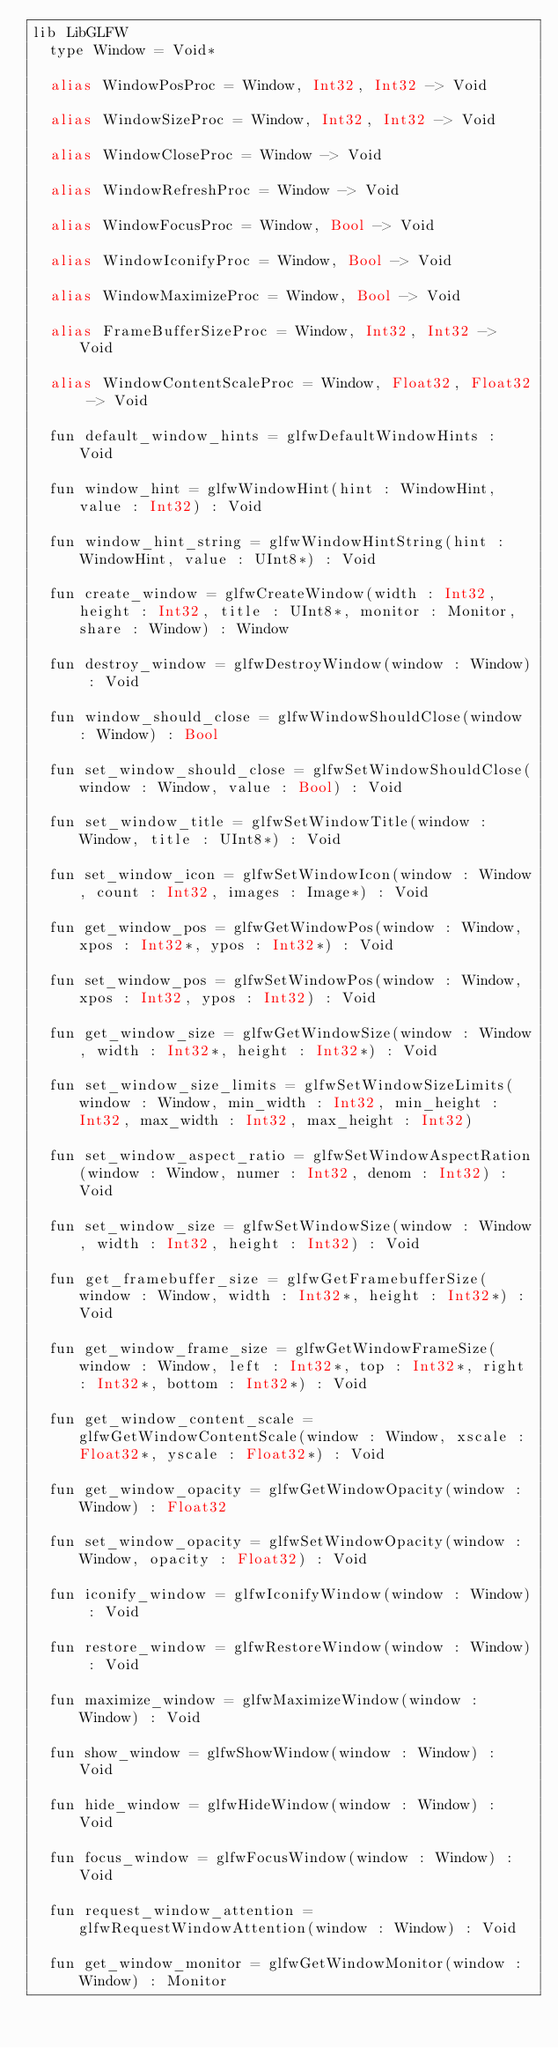Convert code to text. <code><loc_0><loc_0><loc_500><loc_500><_Crystal_>lib LibGLFW
  type Window = Void*

  alias WindowPosProc = Window, Int32, Int32 -> Void

  alias WindowSizeProc = Window, Int32, Int32 -> Void

  alias WindowCloseProc = Window -> Void

  alias WindowRefreshProc = Window -> Void

  alias WindowFocusProc = Window, Bool -> Void

  alias WindowIconifyProc = Window, Bool -> Void

  alias WindowMaximizeProc = Window, Bool -> Void

  alias FrameBufferSizeProc = Window, Int32, Int32 -> Void

  alias WindowContentScaleProc = Window, Float32, Float32 -> Void

  fun default_window_hints = glfwDefaultWindowHints : Void

  fun window_hint = glfwWindowHint(hint : WindowHint, value : Int32) : Void

  fun window_hint_string = glfwWindowHintString(hint : WindowHint, value : UInt8*) : Void

  fun create_window = glfwCreateWindow(width : Int32, height : Int32, title : UInt8*, monitor : Monitor, share : Window) : Window

  fun destroy_window = glfwDestroyWindow(window : Window) : Void

  fun window_should_close = glfwWindowShouldClose(window : Window) : Bool

  fun set_window_should_close = glfwSetWindowShouldClose(window : Window, value : Bool) : Void

  fun set_window_title = glfwSetWindowTitle(window : Window, title : UInt8*) : Void

  fun set_window_icon = glfwSetWindowIcon(window : Window, count : Int32, images : Image*) : Void

  fun get_window_pos = glfwGetWindowPos(window : Window, xpos : Int32*, ypos : Int32*) : Void

  fun set_window_pos = glfwSetWindowPos(window : Window, xpos : Int32, ypos : Int32) : Void

  fun get_window_size = glfwGetWindowSize(window : Window, width : Int32*, height : Int32*) : Void

  fun set_window_size_limits = glfwSetWindowSizeLimits(window : Window, min_width : Int32, min_height : Int32, max_width : Int32, max_height : Int32)

  fun set_window_aspect_ratio = glfwSetWindowAspectRation(window : Window, numer : Int32, denom : Int32) : Void

  fun set_window_size = glfwSetWindowSize(window : Window, width : Int32, height : Int32) : Void

  fun get_framebuffer_size = glfwGetFramebufferSize(window : Window, width : Int32*, height : Int32*) : Void

  fun get_window_frame_size = glfwGetWindowFrameSize(window : Window, left : Int32*, top : Int32*, right : Int32*, bottom : Int32*) : Void

  fun get_window_content_scale = glfwGetWindowContentScale(window : Window, xscale : Float32*, yscale : Float32*) : Void

  fun get_window_opacity = glfwGetWindowOpacity(window : Window) : Float32

  fun set_window_opacity = glfwSetWindowOpacity(window : Window, opacity : Float32) : Void

  fun iconify_window = glfwIconifyWindow(window : Window) : Void

  fun restore_window = glfwRestoreWindow(window : Window) : Void

  fun maximize_window = glfwMaximizeWindow(window : Window) : Void

  fun show_window = glfwShowWindow(window : Window) : Void

  fun hide_window = glfwHideWindow(window : Window) : Void

  fun focus_window = glfwFocusWindow(window : Window) : Void

  fun request_window_attention = glfwRequestWindowAttention(window : Window) : Void

  fun get_window_monitor = glfwGetWindowMonitor(window : Window) : Monitor
</code> 